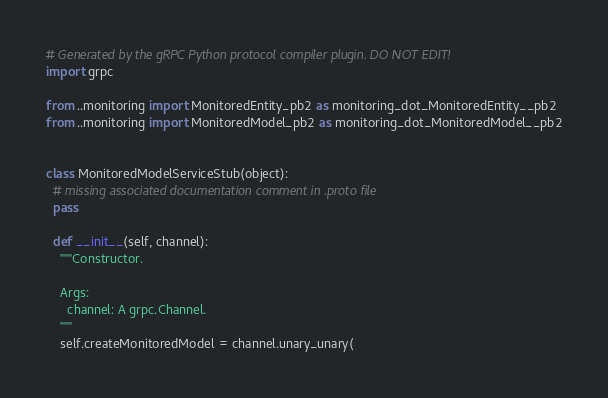<code> <loc_0><loc_0><loc_500><loc_500><_Python_># Generated by the gRPC Python protocol compiler plugin. DO NOT EDIT!
import grpc

from ..monitoring import MonitoredEntity_pb2 as monitoring_dot_MonitoredEntity__pb2
from ..monitoring import MonitoredModel_pb2 as monitoring_dot_MonitoredModel__pb2


class MonitoredModelServiceStub(object):
  # missing associated documentation comment in .proto file
  pass

  def __init__(self, channel):
    """Constructor.

    Args:
      channel: A grpc.Channel.
    """
    self.createMonitoredModel = channel.unary_unary(</code> 